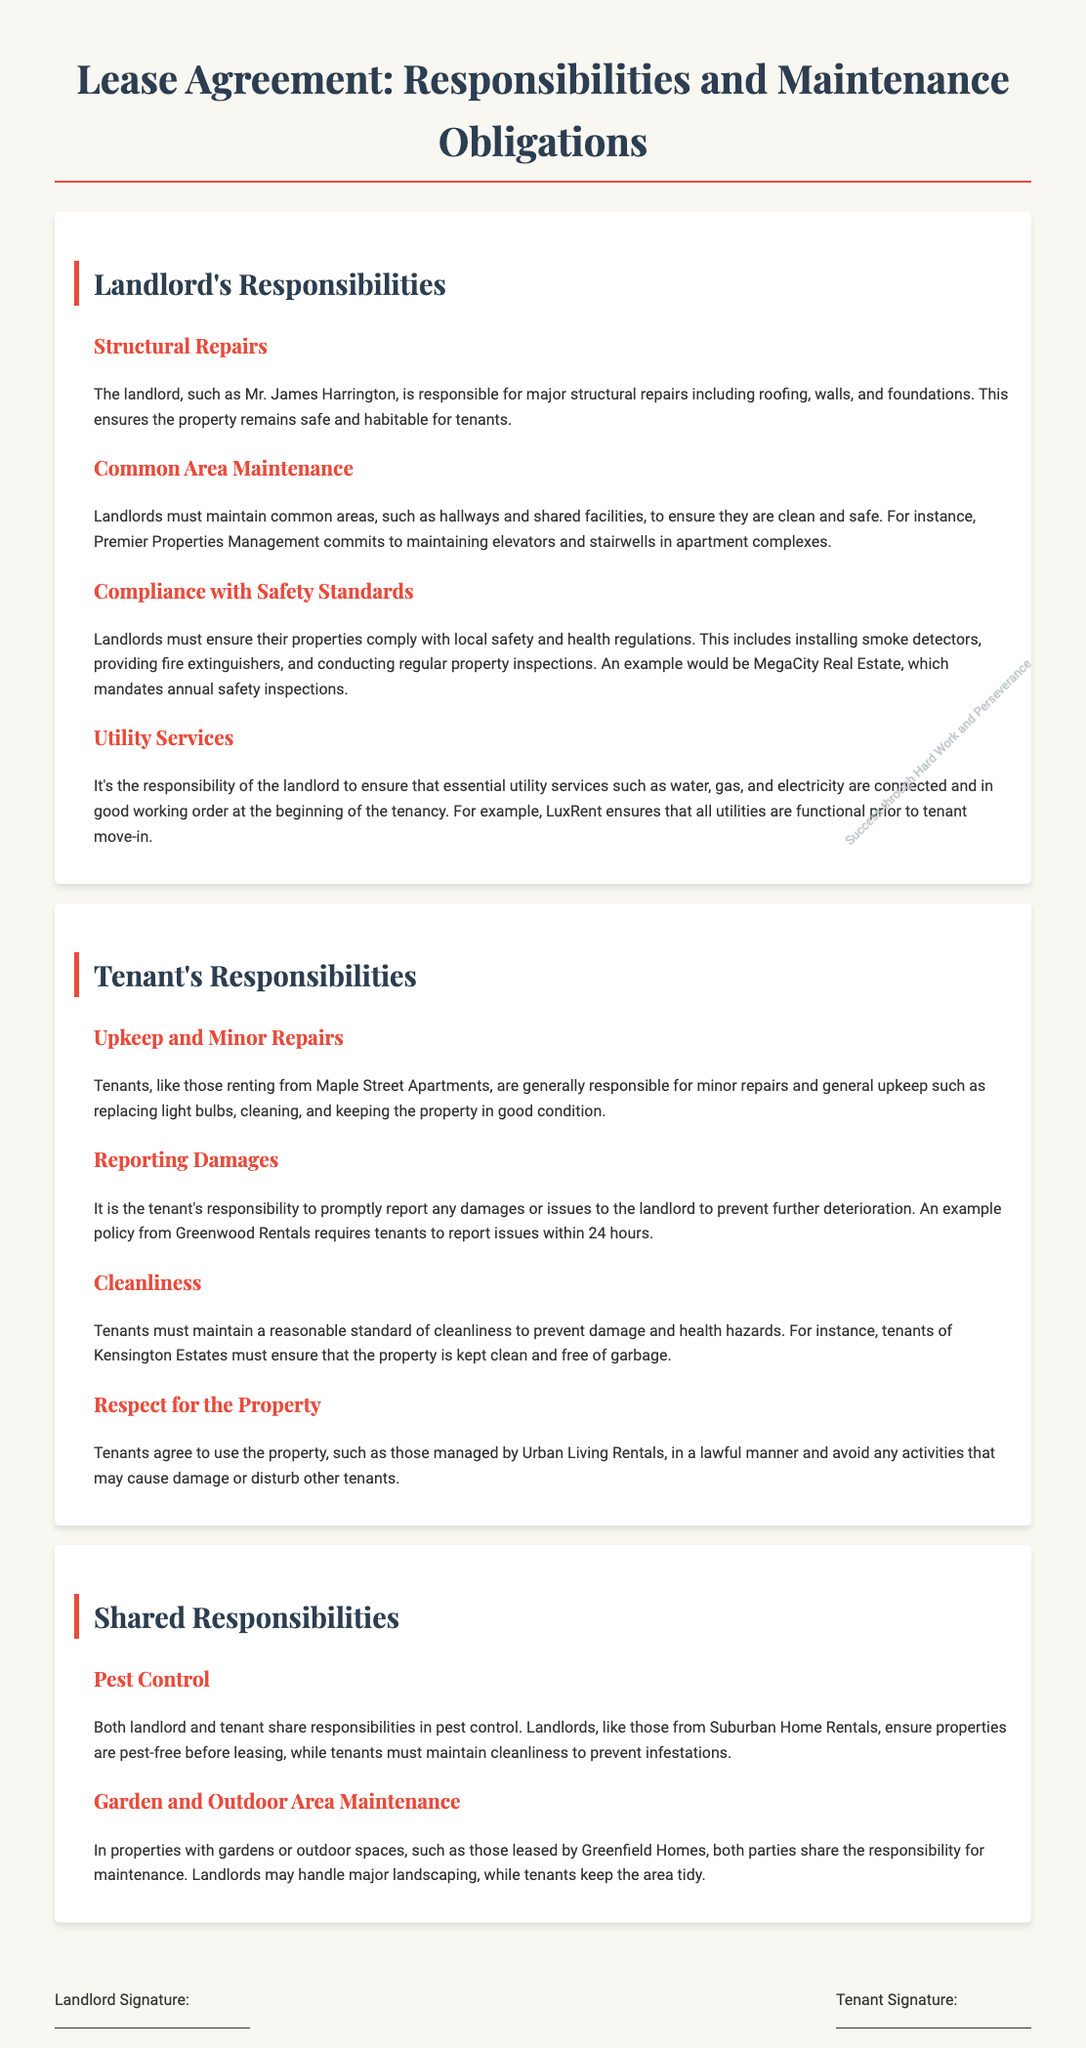What are the landlord's major structural repair responsibilities? Landlords are responsible for major structural repairs including roofing, walls, and foundations to ensure the property remains safe and habitable.
Answer: Structural repairs What must landlords maintain in apartment complexes? Landlords must maintain common areas, such as hallways and shared facilities, including elevators and stairwells in apartment complexes.
Answer: Common areas What are tenants responsible for in terms of minor repairs? Tenants are generally responsible for minor repairs and general upkeep such as replacing light bulbs and cleaning.
Answer: Minor repairs How quickly must tenants report issues or damages? Tenants are required to report issues within 24 hours to prevent further deterioration.
Answer: 24 hours What type of maintenance do both landlord and tenant share? Both parties share responsibilities in pest control, maintaining the property pest-free and clean to prevent infestations.
Answer: Pest control Which utility services must landlords ensure are in good working order? Landlords must ensure that essential utility services such as water, gas, and electricity are connected and functional at the beginning of the tenancy.
Answer: Utility services What is an example of tenant responsibilities regarding property use? Tenants must agree to use the property in a lawful manner and avoid activities that may cause damage or disturb other tenants.
Answer: Lawful manner Who is responsible for maintaining gardens or outdoor areas? Both parties share responsibility, with landlords handling major landscaping and tenants keeping the area tidy.
Answer: Maintenance of gardens What is the lease agreement's purpose in terms of responsibilities? The lease agreement outlines the responsibilities and maintenance obligations of both the landlord and tenant, including repairs and upkeep.
Answer: Outline responsibilities 